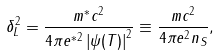<formula> <loc_0><loc_0><loc_500><loc_500>\delta _ { L } ^ { 2 } = \frac { m ^ { \ast } c ^ { 2 } } { 4 \pi e ^ { \ast 2 } \left | \psi ( T ) \right | ^ { 2 } } \equiv \frac { m c ^ { 2 } } { 4 \pi e ^ { 2 } n _ { S } } ,</formula> 